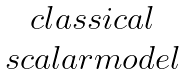Convert formula to latex. <formula><loc_0><loc_0><loc_500><loc_500>\begin{matrix} c l a s s i c a l \\ s c a l a r m o d e l \end{matrix}</formula> 